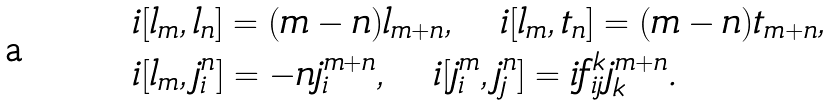Convert formula to latex. <formula><loc_0><loc_0><loc_500><loc_500>& i [ l _ { m } , l _ { n } ] = ( m - n ) l _ { m + n } , \quad i [ l _ { m } , t _ { n } ] = ( m - n ) t _ { m + n } , \\ & i [ l _ { m } , j ^ { n } _ { i } ] = - n j ^ { m + n } _ { i } , \quad i [ j ^ { m } _ { i } , j ^ { n } _ { j } ] = i f _ { i j } ^ { k } j ^ { m + n } _ { k } .</formula> 